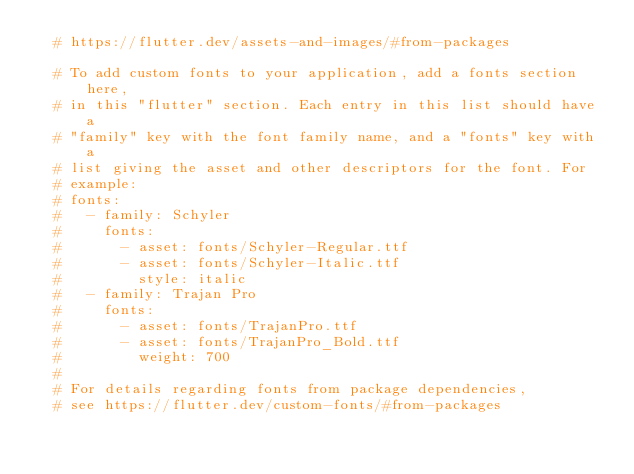Convert code to text. <code><loc_0><loc_0><loc_500><loc_500><_YAML_>  # https://flutter.dev/assets-and-images/#from-packages

  # To add custom fonts to your application, add a fonts section here,
  # in this "flutter" section. Each entry in this list should have a
  # "family" key with the font family name, and a "fonts" key with a
  # list giving the asset and other descriptors for the font. For
  # example:
  # fonts:
  #   - family: Schyler
  #     fonts:
  #       - asset: fonts/Schyler-Regular.ttf
  #       - asset: fonts/Schyler-Italic.ttf
  #         style: italic
  #   - family: Trajan Pro
  #     fonts:
  #       - asset: fonts/TrajanPro.ttf
  #       - asset: fonts/TrajanPro_Bold.ttf
  #         weight: 700
  #
  # For details regarding fonts from package dependencies,
  # see https://flutter.dev/custom-fonts/#from-packages
</code> 